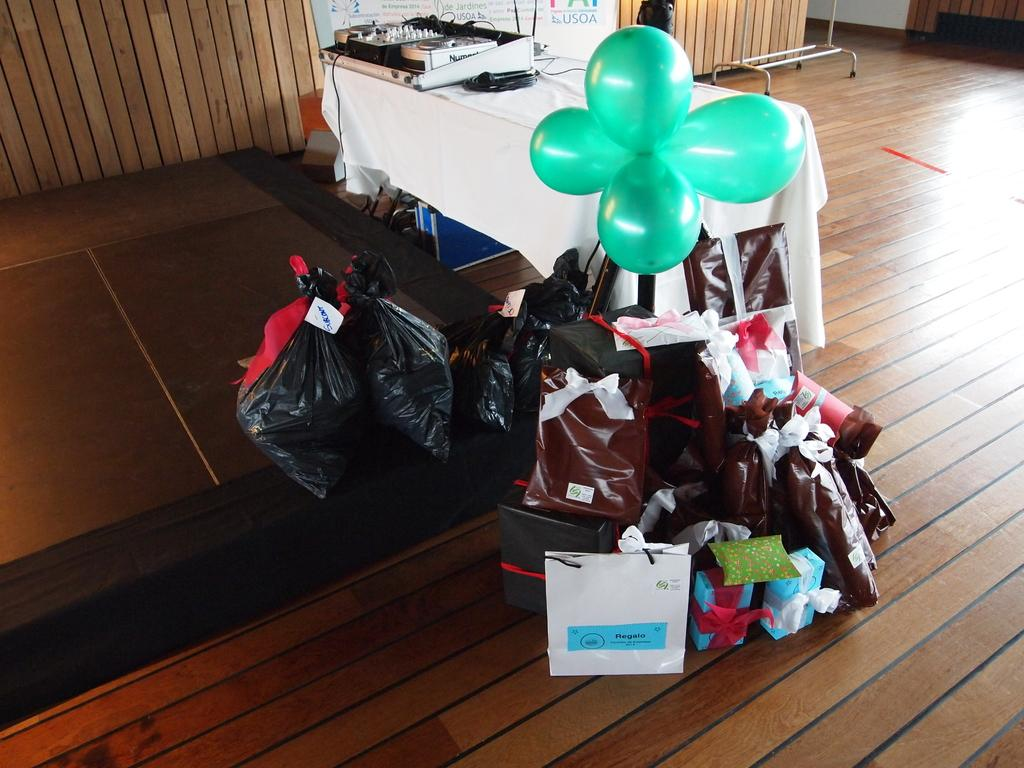What piece of furniture is present in the image? There is a table in the image. What is placed on the table? There is a musical instrument on the table. What can be seen in the middle of the image? There are balloons, garbage bags, and gifts in the middle of the image. What does the queen do to promote learning and expansion in the image? There is no queen present in the image, and therefore no such actions can be observed. 